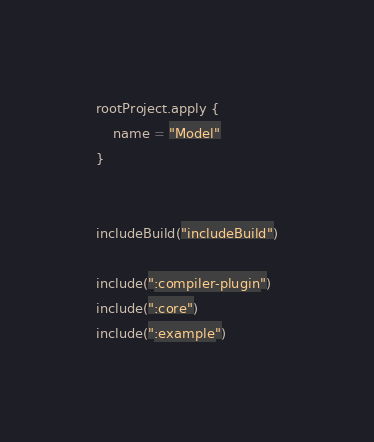Convert code to text. <code><loc_0><loc_0><loc_500><loc_500><_Kotlin_>rootProject.apply {
	name = "Model"
}


includeBuild("includeBuild")

include(":compiler-plugin")
include(":core")
include(":example")
</code> 